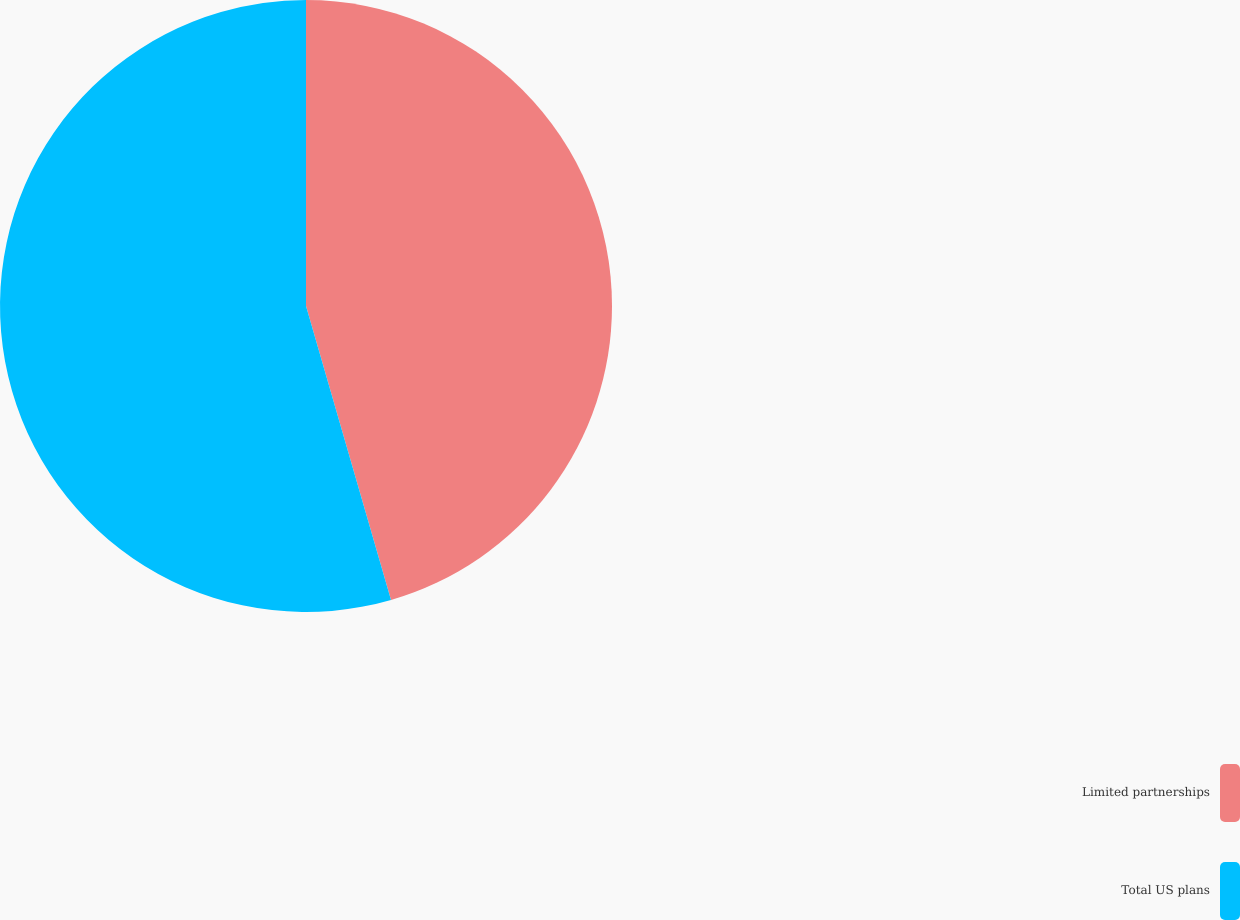Convert chart. <chart><loc_0><loc_0><loc_500><loc_500><pie_chart><fcel>Limited partnerships<fcel>Total US plans<nl><fcel>45.52%<fcel>54.48%<nl></chart> 